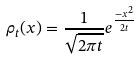Convert formula to latex. <formula><loc_0><loc_0><loc_500><loc_500>\rho _ { t } ( x ) = \frac { 1 } { \sqrt { 2 \pi t } } e ^ { \frac { - x ^ { 2 } } { 2 t } }</formula> 